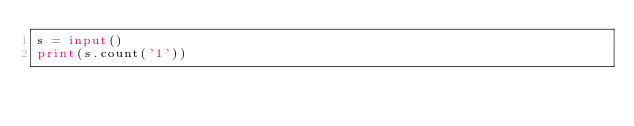<code> <loc_0><loc_0><loc_500><loc_500><_Python_>s = input()
print(s.count('1'))</code> 